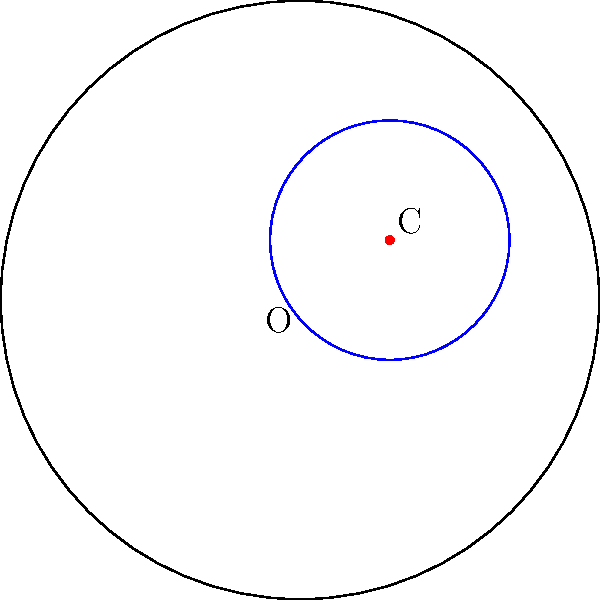In the Poincaré disk model of hyperbolic geometry shown above, a circle is drawn with center C. How does the area of this hyperbolic circle compare to a Euclidean circle with the same radius, and how might this difference influence the design of circular architectural elements in spaces adhering to non-Euclidean geometry? To understand the difference between hyperbolic and Euclidean circles:

1. In Euclidean geometry, the area of a circle is given by $A = \pi r^2$, where $r$ is the radius.

2. In hyperbolic geometry, using the Poincaré disk model, the area of a circle is given by:

   $A = 4\pi \sinh^2(\frac{r}{2})$

   Where $\sinh$ is the hyperbolic sine function, and $r$ is the hyperbolic radius.

3. For small radii, hyperbolic and Euclidean areas are similar. However, as the radius increases, the hyperbolic area grows exponentially faster than the Euclidean area.

4. This means that in hyperbolic space, circular architectural elements would enclose much more area than expected in Euclidean space, especially for larger radii.

5. Architects working in non-Euclidean spaces would need to account for this increased area when designing circular elements, potentially leading to:
   a) More spacious interiors than visually apparent from the outside
   b) Altered acoustics due to the unexpected volume
   c) Challenges in material estimation and structural support

6. This could inspire innovative designs that play with perception, creating spaces that feel larger on the inside than they appear from the exterior.

7. Circular elements might be used more frequently or in novel ways to take advantage of this property, potentially influencing Armstrong's style in hypothetical non-Euclidean projects.
Answer: Hyperbolic circles have larger areas than Euclidean circles of the same radius, exponentially increasing with size, potentially inspiring more spacious and perceptually complex circular architectural elements. 